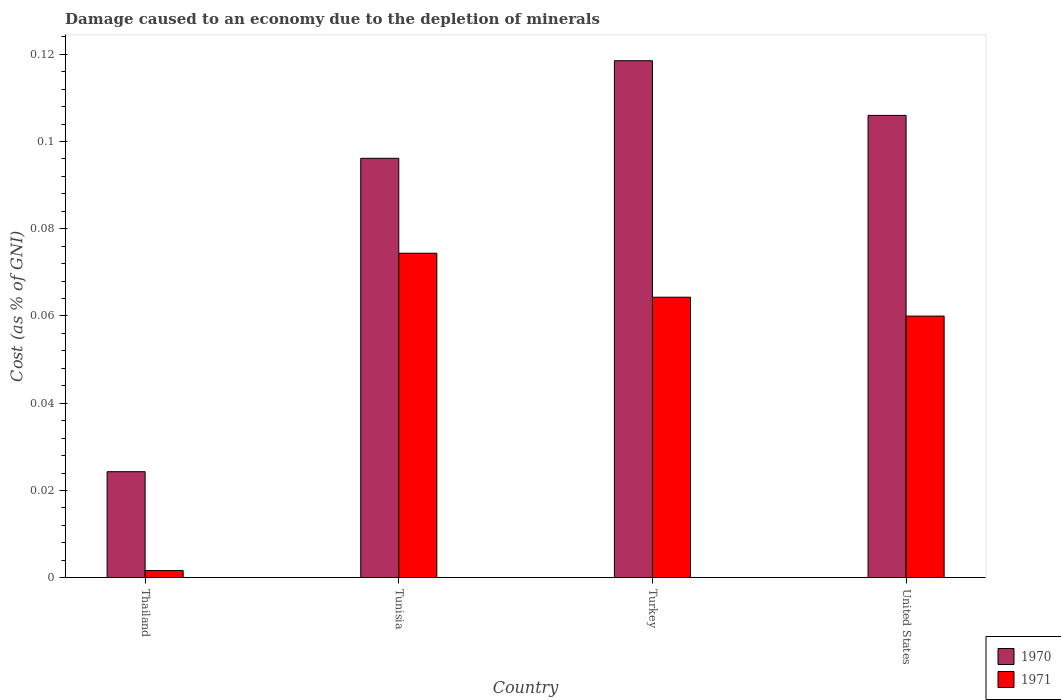How many different coloured bars are there?
Provide a short and direct response. 2. Are the number of bars on each tick of the X-axis equal?
Your response must be concise. Yes. How many bars are there on the 2nd tick from the left?
Your response must be concise. 2. How many bars are there on the 4th tick from the right?
Make the answer very short. 2. What is the label of the 1st group of bars from the left?
Offer a terse response. Thailand. What is the cost of damage caused due to the depletion of minerals in 1971 in Thailand?
Make the answer very short. 0. Across all countries, what is the maximum cost of damage caused due to the depletion of minerals in 1970?
Your answer should be compact. 0.12. Across all countries, what is the minimum cost of damage caused due to the depletion of minerals in 1970?
Offer a terse response. 0.02. In which country was the cost of damage caused due to the depletion of minerals in 1971 maximum?
Make the answer very short. Tunisia. In which country was the cost of damage caused due to the depletion of minerals in 1971 minimum?
Offer a very short reply. Thailand. What is the total cost of damage caused due to the depletion of minerals in 1970 in the graph?
Offer a very short reply. 0.34. What is the difference between the cost of damage caused due to the depletion of minerals in 1970 in Tunisia and that in United States?
Ensure brevity in your answer.  -0.01. What is the difference between the cost of damage caused due to the depletion of minerals in 1970 in United States and the cost of damage caused due to the depletion of minerals in 1971 in Tunisia?
Give a very brief answer. 0.03. What is the average cost of damage caused due to the depletion of minerals in 1971 per country?
Your response must be concise. 0.05. What is the difference between the cost of damage caused due to the depletion of minerals of/in 1970 and cost of damage caused due to the depletion of minerals of/in 1971 in Tunisia?
Your answer should be very brief. 0.02. What is the ratio of the cost of damage caused due to the depletion of minerals in 1971 in Tunisia to that in Turkey?
Provide a short and direct response. 1.16. Is the cost of damage caused due to the depletion of minerals in 1971 in Thailand less than that in Tunisia?
Give a very brief answer. Yes. Is the difference between the cost of damage caused due to the depletion of minerals in 1970 in Turkey and United States greater than the difference between the cost of damage caused due to the depletion of minerals in 1971 in Turkey and United States?
Keep it short and to the point. Yes. What is the difference between the highest and the second highest cost of damage caused due to the depletion of minerals in 1971?
Offer a terse response. 0.01. What is the difference between the highest and the lowest cost of damage caused due to the depletion of minerals in 1971?
Provide a succinct answer. 0.07. In how many countries, is the cost of damage caused due to the depletion of minerals in 1971 greater than the average cost of damage caused due to the depletion of minerals in 1971 taken over all countries?
Your answer should be very brief. 3. What does the 2nd bar from the left in Turkey represents?
Provide a succinct answer. 1971. What does the 1st bar from the right in Tunisia represents?
Provide a short and direct response. 1971. How many bars are there?
Your answer should be compact. 8. How many countries are there in the graph?
Your answer should be compact. 4. What is the difference between two consecutive major ticks on the Y-axis?
Ensure brevity in your answer.  0.02. Are the values on the major ticks of Y-axis written in scientific E-notation?
Offer a terse response. No. Does the graph contain grids?
Provide a short and direct response. No. Where does the legend appear in the graph?
Make the answer very short. Bottom right. How are the legend labels stacked?
Keep it short and to the point. Vertical. What is the title of the graph?
Provide a short and direct response. Damage caused to an economy due to the depletion of minerals. What is the label or title of the Y-axis?
Offer a very short reply. Cost (as % of GNI). What is the Cost (as % of GNI) in 1970 in Thailand?
Your answer should be compact. 0.02. What is the Cost (as % of GNI) of 1971 in Thailand?
Offer a very short reply. 0. What is the Cost (as % of GNI) in 1970 in Tunisia?
Give a very brief answer. 0.1. What is the Cost (as % of GNI) in 1971 in Tunisia?
Ensure brevity in your answer.  0.07. What is the Cost (as % of GNI) in 1970 in Turkey?
Make the answer very short. 0.12. What is the Cost (as % of GNI) in 1971 in Turkey?
Offer a terse response. 0.06. What is the Cost (as % of GNI) in 1970 in United States?
Give a very brief answer. 0.11. What is the Cost (as % of GNI) of 1971 in United States?
Make the answer very short. 0.06. Across all countries, what is the maximum Cost (as % of GNI) in 1970?
Provide a succinct answer. 0.12. Across all countries, what is the maximum Cost (as % of GNI) in 1971?
Offer a terse response. 0.07. Across all countries, what is the minimum Cost (as % of GNI) of 1970?
Your answer should be very brief. 0.02. Across all countries, what is the minimum Cost (as % of GNI) in 1971?
Make the answer very short. 0. What is the total Cost (as % of GNI) in 1970 in the graph?
Provide a short and direct response. 0.34. What is the total Cost (as % of GNI) in 1971 in the graph?
Ensure brevity in your answer.  0.2. What is the difference between the Cost (as % of GNI) in 1970 in Thailand and that in Tunisia?
Offer a very short reply. -0.07. What is the difference between the Cost (as % of GNI) in 1971 in Thailand and that in Tunisia?
Keep it short and to the point. -0.07. What is the difference between the Cost (as % of GNI) in 1970 in Thailand and that in Turkey?
Offer a terse response. -0.09. What is the difference between the Cost (as % of GNI) in 1971 in Thailand and that in Turkey?
Your response must be concise. -0.06. What is the difference between the Cost (as % of GNI) in 1970 in Thailand and that in United States?
Your response must be concise. -0.08. What is the difference between the Cost (as % of GNI) of 1971 in Thailand and that in United States?
Your answer should be very brief. -0.06. What is the difference between the Cost (as % of GNI) in 1970 in Tunisia and that in Turkey?
Your response must be concise. -0.02. What is the difference between the Cost (as % of GNI) of 1971 in Tunisia and that in Turkey?
Keep it short and to the point. 0.01. What is the difference between the Cost (as % of GNI) in 1970 in Tunisia and that in United States?
Your answer should be very brief. -0.01. What is the difference between the Cost (as % of GNI) of 1971 in Tunisia and that in United States?
Provide a succinct answer. 0.01. What is the difference between the Cost (as % of GNI) of 1970 in Turkey and that in United States?
Keep it short and to the point. 0.01. What is the difference between the Cost (as % of GNI) of 1971 in Turkey and that in United States?
Ensure brevity in your answer.  0. What is the difference between the Cost (as % of GNI) in 1970 in Thailand and the Cost (as % of GNI) in 1971 in Tunisia?
Provide a succinct answer. -0.05. What is the difference between the Cost (as % of GNI) of 1970 in Thailand and the Cost (as % of GNI) of 1971 in Turkey?
Keep it short and to the point. -0.04. What is the difference between the Cost (as % of GNI) in 1970 in Thailand and the Cost (as % of GNI) in 1971 in United States?
Offer a very short reply. -0.04. What is the difference between the Cost (as % of GNI) of 1970 in Tunisia and the Cost (as % of GNI) of 1971 in Turkey?
Provide a short and direct response. 0.03. What is the difference between the Cost (as % of GNI) of 1970 in Tunisia and the Cost (as % of GNI) of 1971 in United States?
Ensure brevity in your answer.  0.04. What is the difference between the Cost (as % of GNI) of 1970 in Turkey and the Cost (as % of GNI) of 1971 in United States?
Your response must be concise. 0.06. What is the average Cost (as % of GNI) of 1970 per country?
Your answer should be very brief. 0.09. What is the average Cost (as % of GNI) of 1971 per country?
Provide a short and direct response. 0.05. What is the difference between the Cost (as % of GNI) in 1970 and Cost (as % of GNI) in 1971 in Thailand?
Make the answer very short. 0.02. What is the difference between the Cost (as % of GNI) in 1970 and Cost (as % of GNI) in 1971 in Tunisia?
Make the answer very short. 0.02. What is the difference between the Cost (as % of GNI) of 1970 and Cost (as % of GNI) of 1971 in Turkey?
Ensure brevity in your answer.  0.05. What is the difference between the Cost (as % of GNI) in 1970 and Cost (as % of GNI) in 1971 in United States?
Make the answer very short. 0.05. What is the ratio of the Cost (as % of GNI) of 1970 in Thailand to that in Tunisia?
Your answer should be very brief. 0.25. What is the ratio of the Cost (as % of GNI) in 1971 in Thailand to that in Tunisia?
Your answer should be compact. 0.02. What is the ratio of the Cost (as % of GNI) of 1970 in Thailand to that in Turkey?
Give a very brief answer. 0.21. What is the ratio of the Cost (as % of GNI) of 1971 in Thailand to that in Turkey?
Provide a short and direct response. 0.03. What is the ratio of the Cost (as % of GNI) in 1970 in Thailand to that in United States?
Your answer should be compact. 0.23. What is the ratio of the Cost (as % of GNI) of 1971 in Thailand to that in United States?
Ensure brevity in your answer.  0.03. What is the ratio of the Cost (as % of GNI) in 1970 in Tunisia to that in Turkey?
Offer a very short reply. 0.81. What is the ratio of the Cost (as % of GNI) in 1971 in Tunisia to that in Turkey?
Provide a short and direct response. 1.16. What is the ratio of the Cost (as % of GNI) in 1970 in Tunisia to that in United States?
Offer a terse response. 0.91. What is the ratio of the Cost (as % of GNI) in 1971 in Tunisia to that in United States?
Keep it short and to the point. 1.24. What is the ratio of the Cost (as % of GNI) of 1970 in Turkey to that in United States?
Your answer should be compact. 1.12. What is the ratio of the Cost (as % of GNI) of 1971 in Turkey to that in United States?
Your answer should be compact. 1.07. What is the difference between the highest and the second highest Cost (as % of GNI) of 1970?
Offer a very short reply. 0.01. What is the difference between the highest and the second highest Cost (as % of GNI) in 1971?
Your answer should be very brief. 0.01. What is the difference between the highest and the lowest Cost (as % of GNI) in 1970?
Your response must be concise. 0.09. What is the difference between the highest and the lowest Cost (as % of GNI) in 1971?
Make the answer very short. 0.07. 